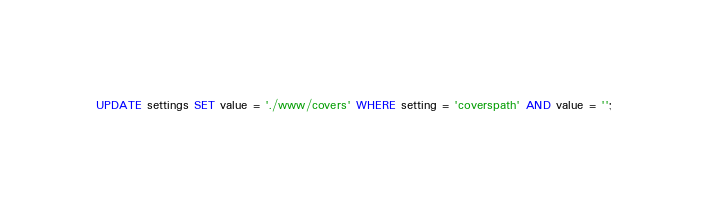<code> <loc_0><loc_0><loc_500><loc_500><_SQL_>UPDATE settings SET value = './www/covers' WHERE setting = 'coverspath' AND value = '';
</code> 